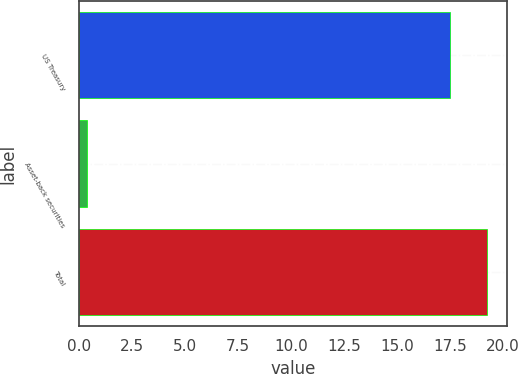Convert chart to OTSL. <chart><loc_0><loc_0><loc_500><loc_500><bar_chart><fcel>US Treasury<fcel>Asset-back securities<fcel>Total<nl><fcel>17.5<fcel>0.4<fcel>19.25<nl></chart> 